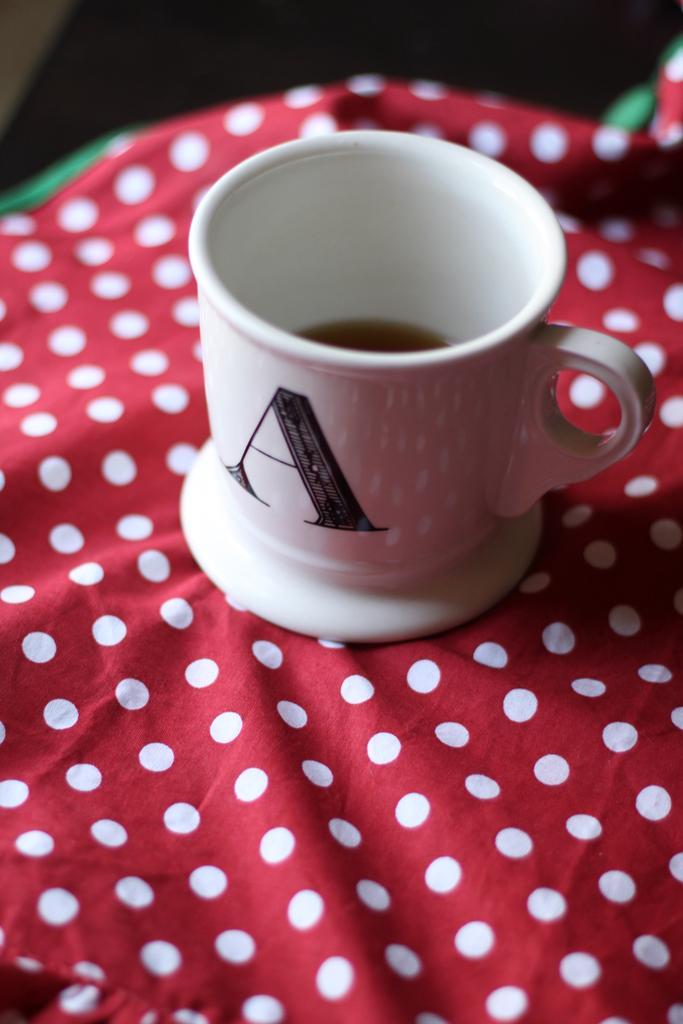How would you summarize this image in a sentence or two? In this image we can see there is a cup on the cloth. 